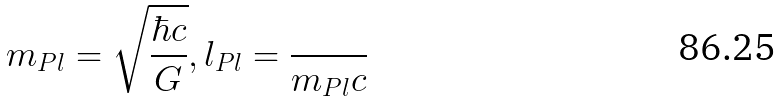<formula> <loc_0><loc_0><loc_500><loc_500>m _ { P l } = \sqrt { \frac { \hbar { c } } { G } } , l _ { P l } = \frac { } { m _ { P l } c }</formula> 